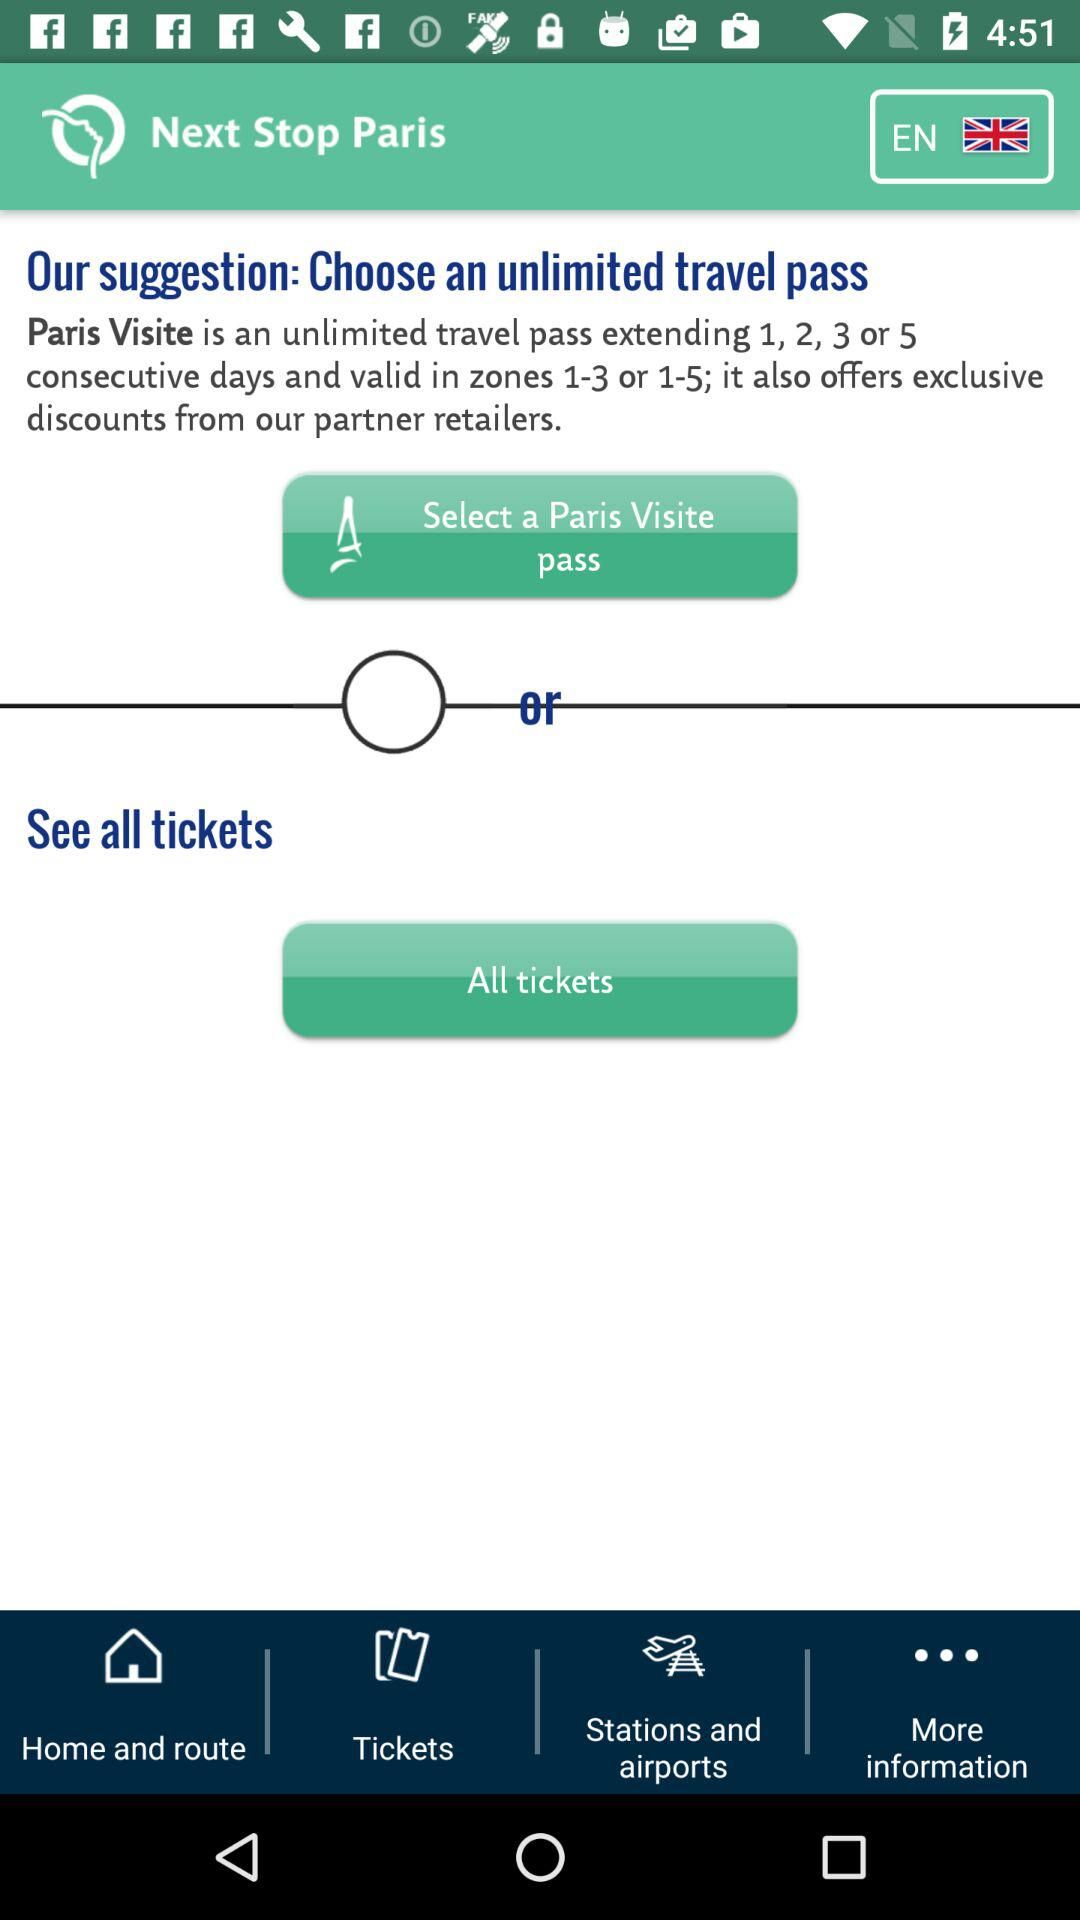What is the name of the unlimited travel pass? The name of the unlimited travel pass is "Paris Visite". 